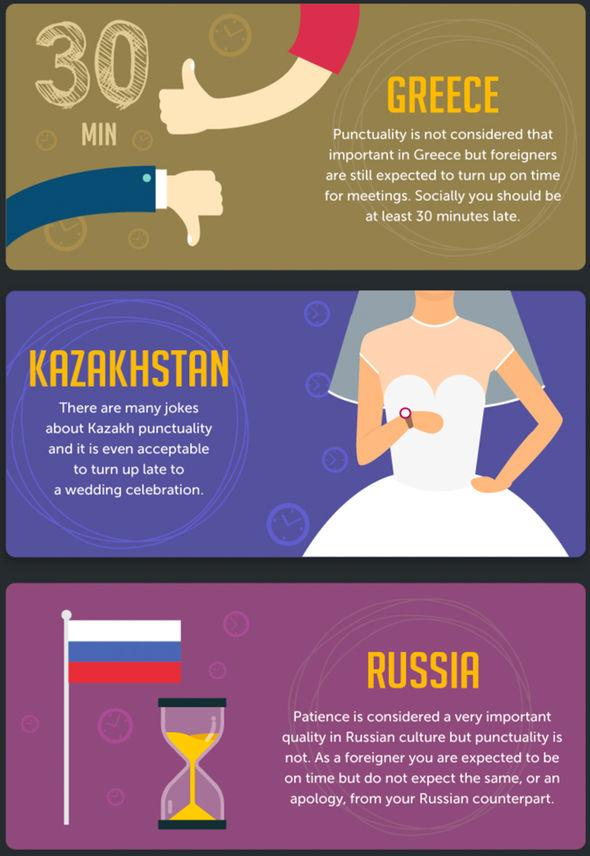Specify some key components in this picture. The image shows the flag of Russia, a country known for its rich history and cultural heritage. The bride is wearing a watch on her hand. The image used to represent the importance of punctuality in Kazakhstan is a bride, emphasizing the importance of punctuality as a symbol of respect and reliability. It is considered acceptable in Greece to be 30 minutes late for social gatherings. In Russia, patience is considered to be more important than punctuality. 